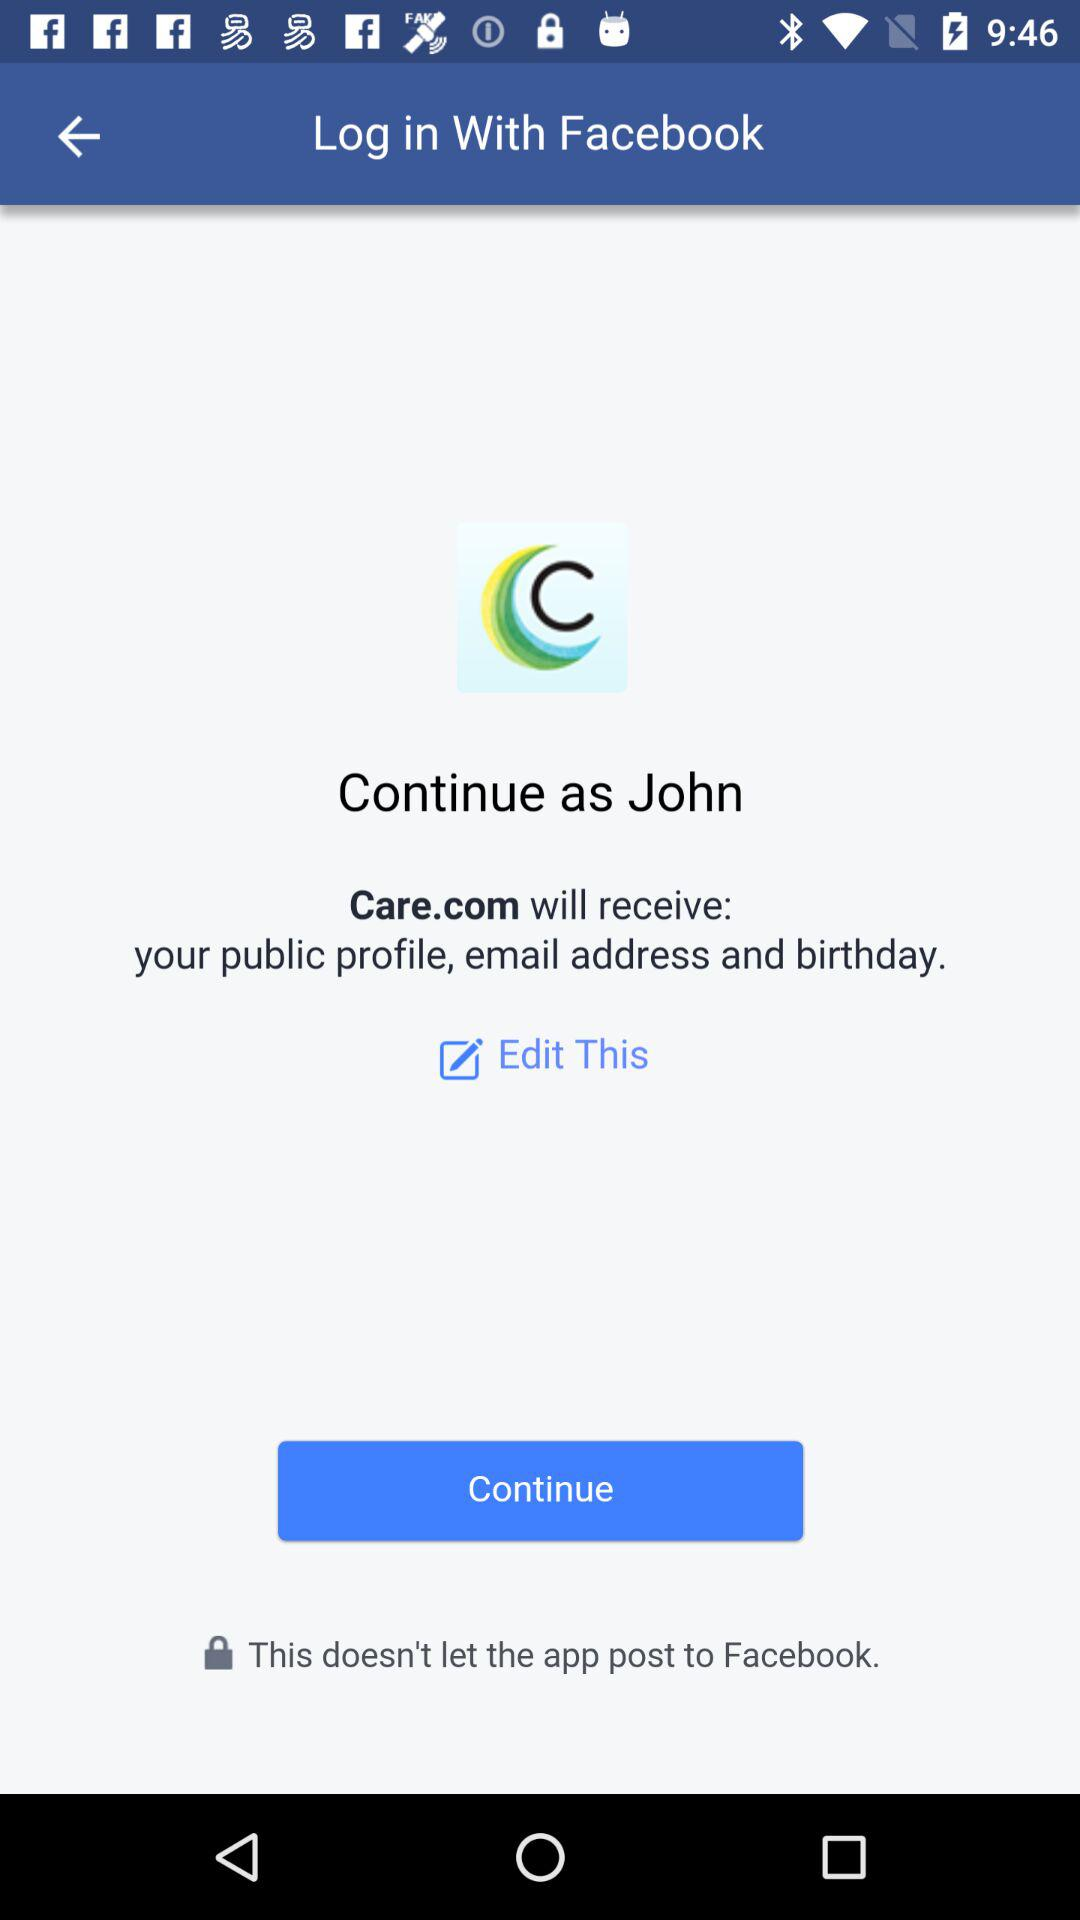What is log in name? The log in name is John. 